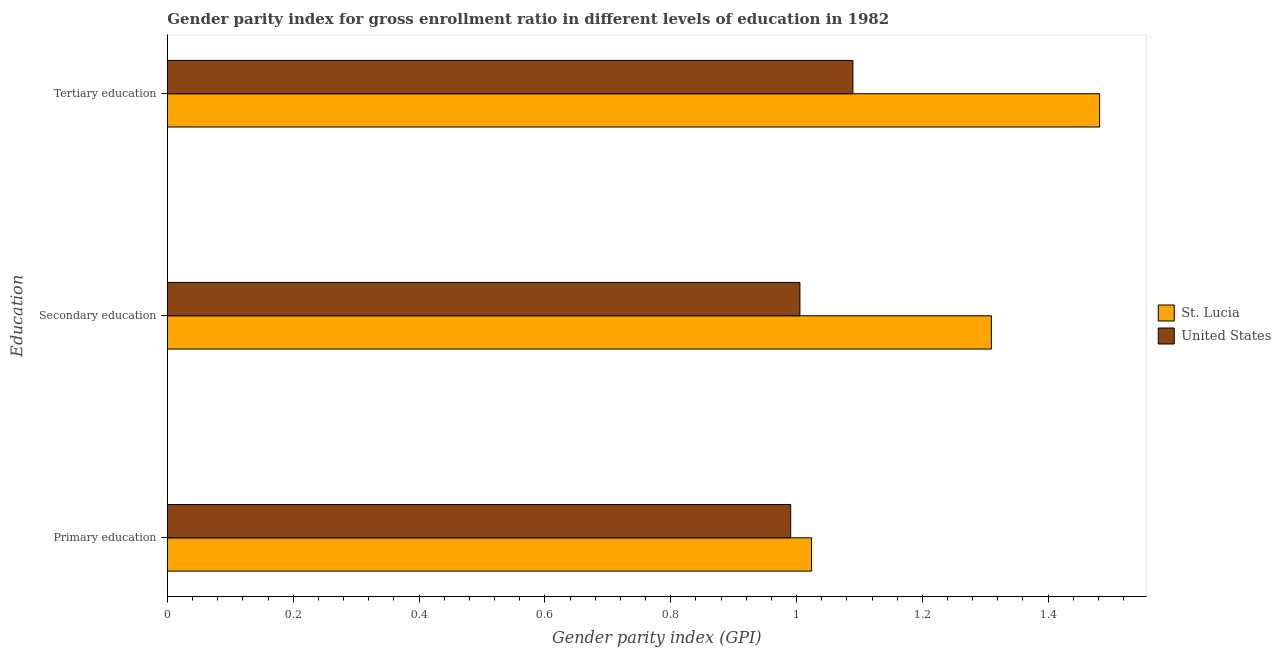How many groups of bars are there?
Offer a very short reply. 3. How many bars are there on the 1st tick from the top?
Make the answer very short. 2. What is the gender parity index in tertiary education in St. Lucia?
Your response must be concise. 1.48. Across all countries, what is the maximum gender parity index in primary education?
Offer a very short reply. 1.02. Across all countries, what is the minimum gender parity index in primary education?
Give a very brief answer. 0.99. In which country was the gender parity index in primary education maximum?
Ensure brevity in your answer.  St. Lucia. In which country was the gender parity index in secondary education minimum?
Keep it short and to the point. United States. What is the total gender parity index in secondary education in the graph?
Provide a short and direct response. 2.32. What is the difference between the gender parity index in tertiary education in United States and that in St. Lucia?
Offer a very short reply. -0.39. What is the difference between the gender parity index in primary education in St. Lucia and the gender parity index in tertiary education in United States?
Provide a succinct answer. -0.07. What is the average gender parity index in tertiary education per country?
Keep it short and to the point. 1.29. What is the difference between the gender parity index in tertiary education and gender parity index in primary education in St. Lucia?
Give a very brief answer. 0.46. What is the ratio of the gender parity index in primary education in St. Lucia to that in United States?
Your answer should be very brief. 1.03. Is the gender parity index in tertiary education in St. Lucia less than that in United States?
Offer a terse response. No. Is the difference between the gender parity index in secondary education in United States and St. Lucia greater than the difference between the gender parity index in primary education in United States and St. Lucia?
Offer a terse response. No. What is the difference between the highest and the second highest gender parity index in primary education?
Your answer should be very brief. 0.03. What is the difference between the highest and the lowest gender parity index in secondary education?
Offer a very short reply. 0.3. In how many countries, is the gender parity index in secondary education greater than the average gender parity index in secondary education taken over all countries?
Your response must be concise. 1. What does the 2nd bar from the top in Secondary education represents?
Provide a succinct answer. St. Lucia. What does the 1st bar from the bottom in Secondary education represents?
Your answer should be very brief. St. Lucia. Is it the case that in every country, the sum of the gender parity index in primary education and gender parity index in secondary education is greater than the gender parity index in tertiary education?
Your answer should be compact. Yes. Are all the bars in the graph horizontal?
Keep it short and to the point. Yes. How many countries are there in the graph?
Your response must be concise. 2. Are the values on the major ticks of X-axis written in scientific E-notation?
Provide a short and direct response. No. Does the graph contain any zero values?
Your response must be concise. No. Does the graph contain grids?
Provide a short and direct response. No. Where does the legend appear in the graph?
Keep it short and to the point. Center right. How many legend labels are there?
Your response must be concise. 2. How are the legend labels stacked?
Your answer should be compact. Vertical. What is the title of the graph?
Your answer should be very brief. Gender parity index for gross enrollment ratio in different levels of education in 1982. What is the label or title of the X-axis?
Your answer should be compact. Gender parity index (GPI). What is the label or title of the Y-axis?
Make the answer very short. Education. What is the Gender parity index (GPI) of St. Lucia in Primary education?
Give a very brief answer. 1.02. What is the Gender parity index (GPI) of United States in Primary education?
Your response must be concise. 0.99. What is the Gender parity index (GPI) in St. Lucia in Secondary education?
Give a very brief answer. 1.31. What is the Gender parity index (GPI) in United States in Secondary education?
Make the answer very short. 1.01. What is the Gender parity index (GPI) of St. Lucia in Tertiary education?
Offer a terse response. 1.48. What is the Gender parity index (GPI) of United States in Tertiary education?
Your answer should be compact. 1.09. Across all Education, what is the maximum Gender parity index (GPI) in St. Lucia?
Make the answer very short. 1.48. Across all Education, what is the maximum Gender parity index (GPI) in United States?
Give a very brief answer. 1.09. Across all Education, what is the minimum Gender parity index (GPI) of St. Lucia?
Give a very brief answer. 1.02. Across all Education, what is the minimum Gender parity index (GPI) of United States?
Your response must be concise. 0.99. What is the total Gender parity index (GPI) of St. Lucia in the graph?
Give a very brief answer. 3.82. What is the total Gender parity index (GPI) in United States in the graph?
Give a very brief answer. 3.09. What is the difference between the Gender parity index (GPI) in St. Lucia in Primary education and that in Secondary education?
Provide a succinct answer. -0.29. What is the difference between the Gender parity index (GPI) of United States in Primary education and that in Secondary education?
Offer a terse response. -0.01. What is the difference between the Gender parity index (GPI) in St. Lucia in Primary education and that in Tertiary education?
Give a very brief answer. -0.46. What is the difference between the Gender parity index (GPI) in United States in Primary education and that in Tertiary education?
Offer a terse response. -0.1. What is the difference between the Gender parity index (GPI) in St. Lucia in Secondary education and that in Tertiary education?
Offer a very short reply. -0.17. What is the difference between the Gender parity index (GPI) in United States in Secondary education and that in Tertiary education?
Keep it short and to the point. -0.08. What is the difference between the Gender parity index (GPI) of St. Lucia in Primary education and the Gender parity index (GPI) of United States in Secondary education?
Your answer should be very brief. 0.02. What is the difference between the Gender parity index (GPI) in St. Lucia in Primary education and the Gender parity index (GPI) in United States in Tertiary education?
Provide a short and direct response. -0.07. What is the difference between the Gender parity index (GPI) of St. Lucia in Secondary education and the Gender parity index (GPI) of United States in Tertiary education?
Provide a short and direct response. 0.22. What is the average Gender parity index (GPI) of St. Lucia per Education?
Your answer should be compact. 1.27. What is the average Gender parity index (GPI) of United States per Education?
Your answer should be compact. 1.03. What is the difference between the Gender parity index (GPI) in St. Lucia and Gender parity index (GPI) in United States in Primary education?
Keep it short and to the point. 0.03. What is the difference between the Gender parity index (GPI) in St. Lucia and Gender parity index (GPI) in United States in Secondary education?
Your answer should be very brief. 0.3. What is the difference between the Gender parity index (GPI) in St. Lucia and Gender parity index (GPI) in United States in Tertiary education?
Your response must be concise. 0.39. What is the ratio of the Gender parity index (GPI) of St. Lucia in Primary education to that in Secondary education?
Make the answer very short. 0.78. What is the ratio of the Gender parity index (GPI) of United States in Primary education to that in Secondary education?
Make the answer very short. 0.99. What is the ratio of the Gender parity index (GPI) in St. Lucia in Primary education to that in Tertiary education?
Your answer should be very brief. 0.69. What is the ratio of the Gender parity index (GPI) in United States in Primary education to that in Tertiary education?
Provide a succinct answer. 0.91. What is the ratio of the Gender parity index (GPI) in St. Lucia in Secondary education to that in Tertiary education?
Ensure brevity in your answer.  0.88. What is the ratio of the Gender parity index (GPI) of United States in Secondary education to that in Tertiary education?
Keep it short and to the point. 0.92. What is the difference between the highest and the second highest Gender parity index (GPI) of St. Lucia?
Give a very brief answer. 0.17. What is the difference between the highest and the second highest Gender parity index (GPI) in United States?
Offer a very short reply. 0.08. What is the difference between the highest and the lowest Gender parity index (GPI) in St. Lucia?
Offer a very short reply. 0.46. What is the difference between the highest and the lowest Gender parity index (GPI) in United States?
Offer a terse response. 0.1. 